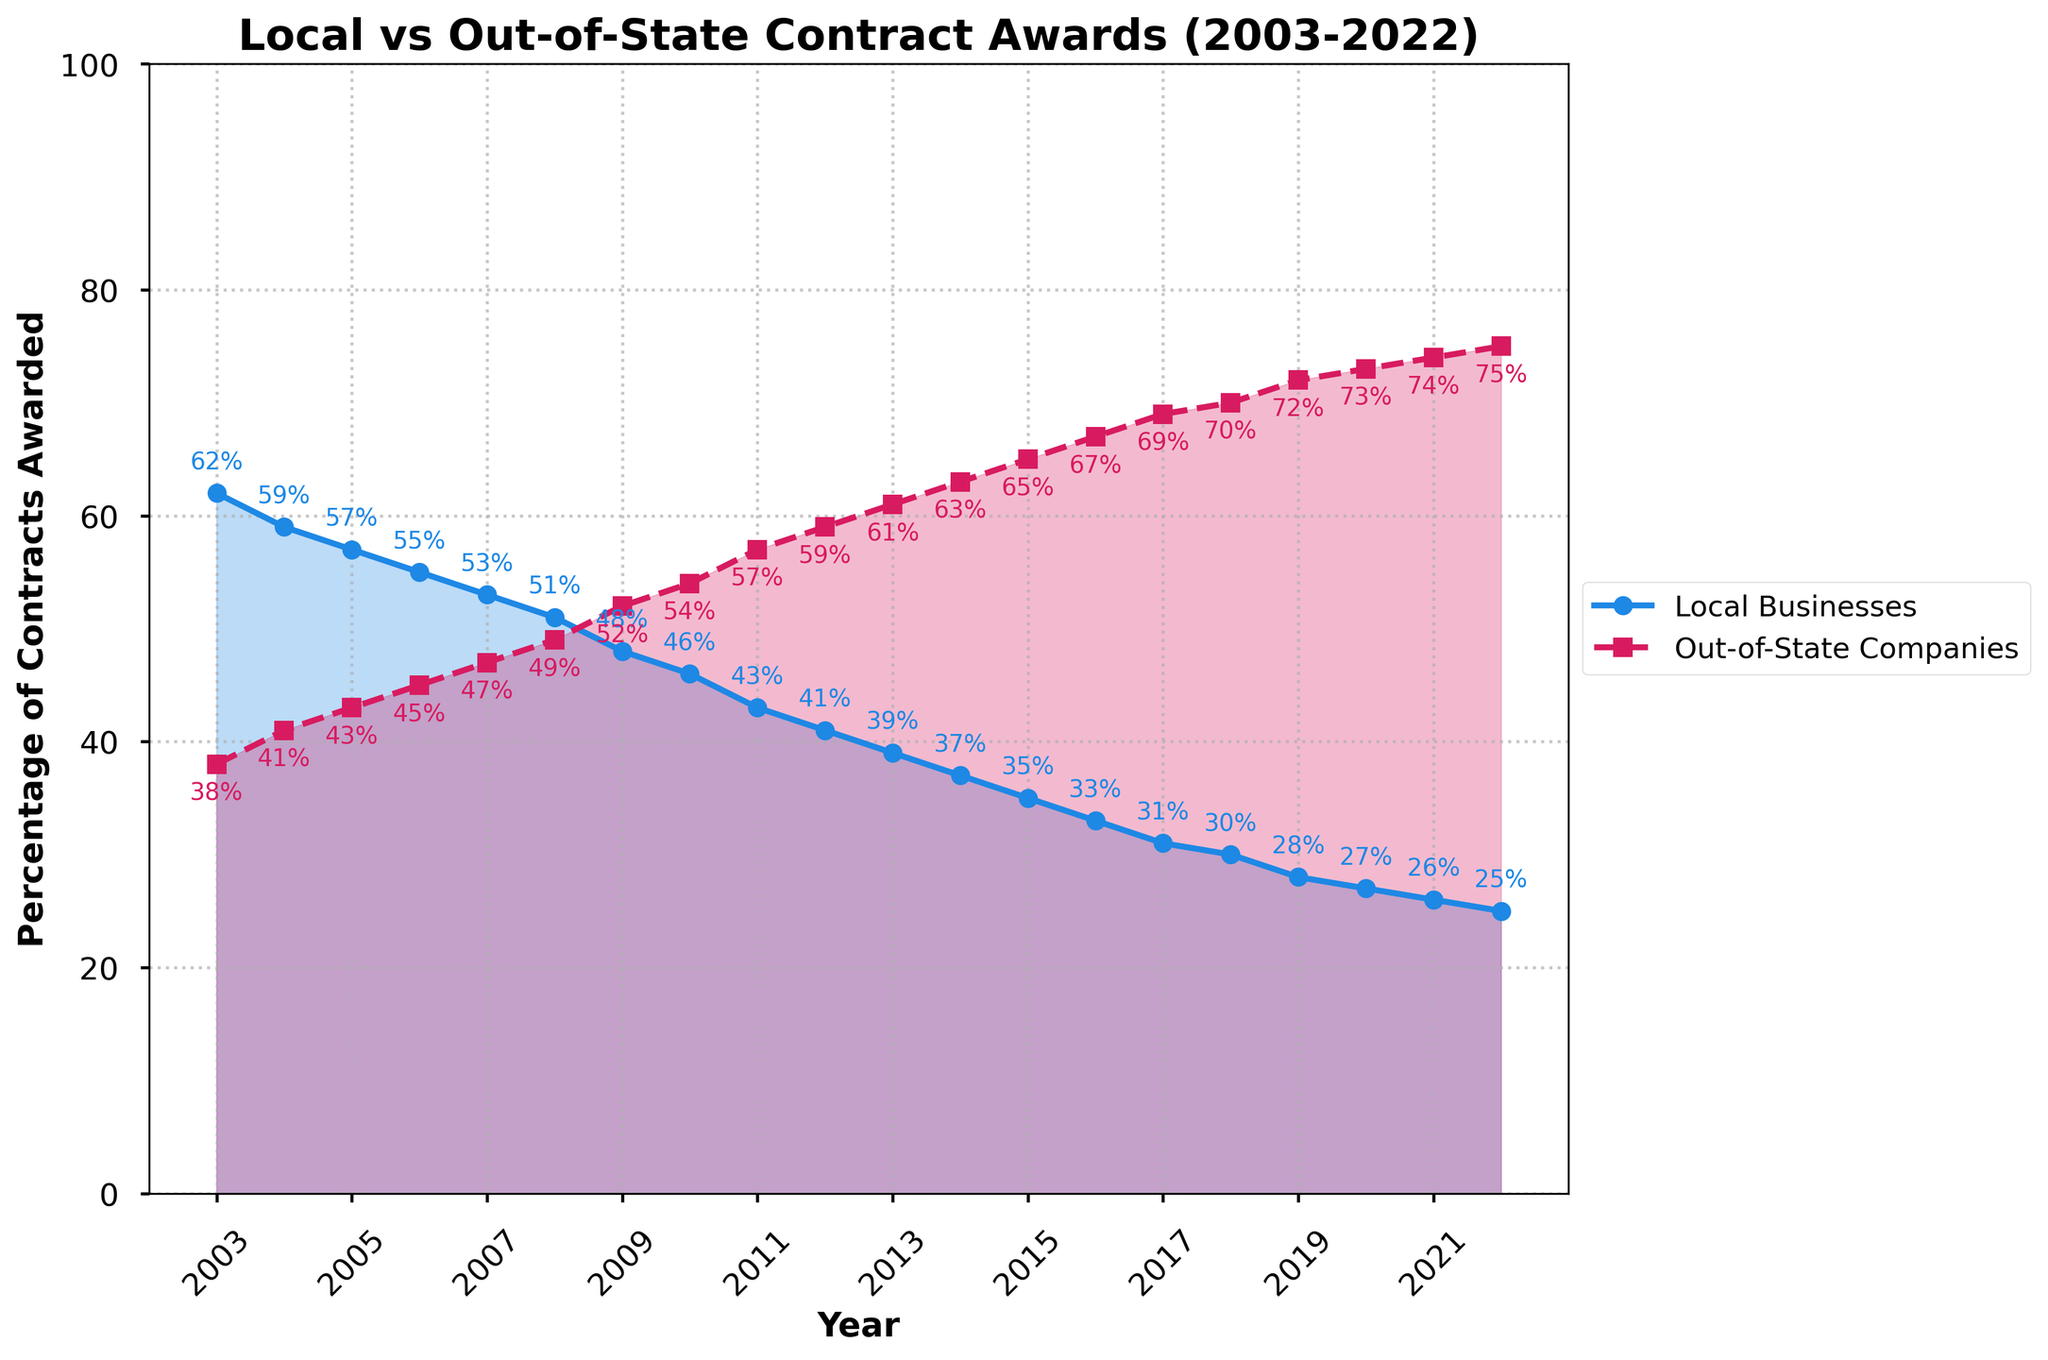What's the percentage difference in contracts awarded to local businesses between 2003 and 2022? To find the percentage difference, subtract the 2022 percentage of local businesses (25%) from the 2003 percentage (62%), which is 62% - 25%.
Answer: 37% At what year do local businesses' contracts drop below 50%? Identify the first year where the plotted line crosses below the 50% mark. This occurs between 2007 and 2008.
Answer: 2008 Describe the trend of contracts awarded to local businesses over the 20-year period. The plot shows a clear, consistent downward trend for local businesses' contracts from 62% in 2003 to 25% in 2022, meaning local businesses are receiving fewer contracts over time.
Answer: Downward trend Which year saw the highest percentage of out-of-state company contracts? Look at the plot and locate the peak point for out-of-state companies, which is the last data point in 2022 with 75%.
Answer: 2022 How much has the percentage of out-of-state company contracts increased from 2003 to 2022? Subtract the percentage of contracts awarded to out-of-state companies in 2003 (38%) from that in 2022 (75%).
Answer: 37% What was the first year out-of-state companies received more than 50% of contracts? Find the year where the percentage of out-of-state companies first crosses above 50%. This happens in 2008.
Answer: 2008 Compare the percentages of contracts awarded to local businesses and out-of-state companies in 2010. In 2010, the chart shows local businesses at 46% and out-of-state at 54%.
Answer: Local: 46%, Out-of-State: 54% What year had equal percentages of contracts awarded to local businesses and out-of-state companies? Identify the year where both lines intersect, which would indicate equal percentages. This is not visibly indicated as equal for any given year, but close to 2008 when they are almost equal but not quite.
Answer: None How did the percentage of contracts to local businesses and out-of-state companies change from 2015 to 2020? For local businesses: in 2015 (35%) to 2020 (27%), a decrease of 8%. For out-of-state companies: in 2015 (65%) to 2020 (73%), an increase of 8%.
Answer: Local: -8%, Out-of-State: +8% Identify the general slope or rate of change for local businesses' contract percentages over the 20-year span. Calculate the slope from 62% in 2003 to 25% in 2022. The rate of change is approximately -1.85% per year, computed by (62-25)/(2022-2003).
Answer: -1.85% per year 